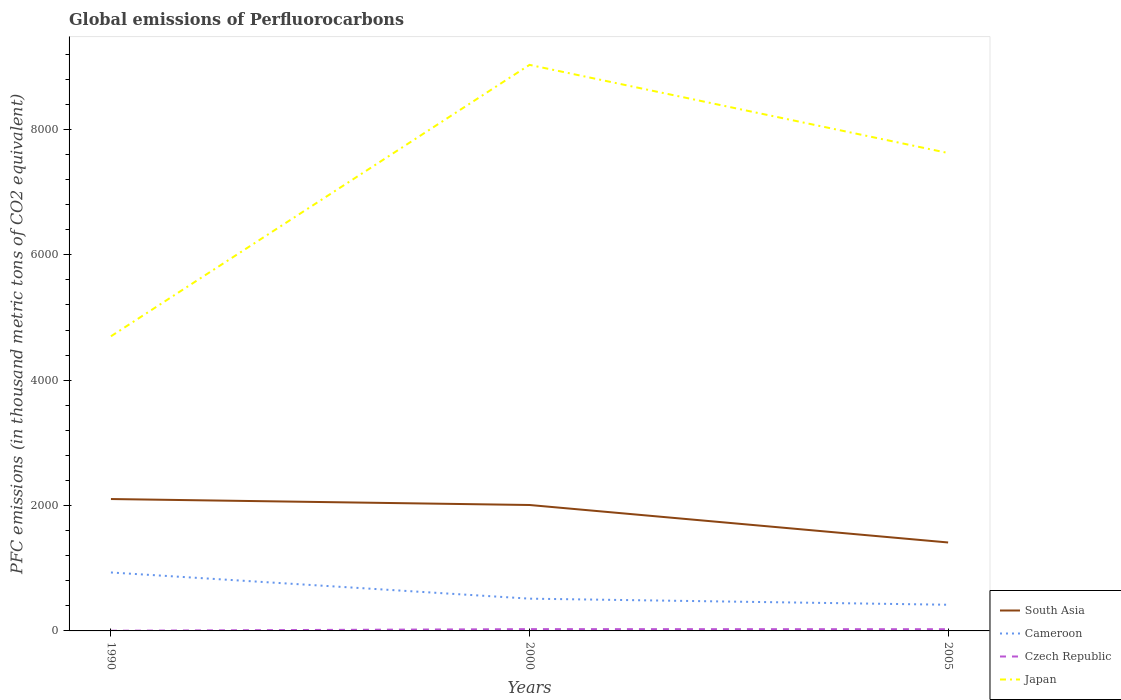How many different coloured lines are there?
Offer a very short reply. 4. Is the number of lines equal to the number of legend labels?
Keep it short and to the point. Yes. Across all years, what is the maximum global emissions of Perfluorocarbons in South Asia?
Your response must be concise. 1410.84. What is the total global emissions of Perfluorocarbons in South Asia in the graph?
Offer a terse response. 95.2. What is the difference between the highest and the second highest global emissions of Perfluorocarbons in Japan?
Provide a succinct answer. 4329.8. Is the global emissions of Perfluorocarbons in South Asia strictly greater than the global emissions of Perfluorocarbons in Czech Republic over the years?
Your response must be concise. No. Does the graph contain any zero values?
Your answer should be compact. No. Does the graph contain grids?
Keep it short and to the point. No. How are the legend labels stacked?
Provide a succinct answer. Vertical. What is the title of the graph?
Offer a terse response. Global emissions of Perfluorocarbons. What is the label or title of the Y-axis?
Your answer should be compact. PFC emissions (in thousand metric tons of CO2 equivalent). What is the PFC emissions (in thousand metric tons of CO2 equivalent) of South Asia in 1990?
Offer a very short reply. 2104. What is the PFC emissions (in thousand metric tons of CO2 equivalent) in Cameroon in 1990?
Keep it short and to the point. 932.3. What is the PFC emissions (in thousand metric tons of CO2 equivalent) of Czech Republic in 1990?
Give a very brief answer. 2.8. What is the PFC emissions (in thousand metric tons of CO2 equivalent) of Japan in 1990?
Your answer should be compact. 4700. What is the PFC emissions (in thousand metric tons of CO2 equivalent) of South Asia in 2000?
Keep it short and to the point. 2008.8. What is the PFC emissions (in thousand metric tons of CO2 equivalent) in Cameroon in 2000?
Make the answer very short. 514.7. What is the PFC emissions (in thousand metric tons of CO2 equivalent) of Czech Republic in 2000?
Offer a very short reply. 28.8. What is the PFC emissions (in thousand metric tons of CO2 equivalent) of Japan in 2000?
Offer a very short reply. 9029.8. What is the PFC emissions (in thousand metric tons of CO2 equivalent) of South Asia in 2005?
Ensure brevity in your answer.  1410.84. What is the PFC emissions (in thousand metric tons of CO2 equivalent) of Cameroon in 2005?
Ensure brevity in your answer.  417.5. What is the PFC emissions (in thousand metric tons of CO2 equivalent) of Japan in 2005?
Make the answer very short. 7623.6. Across all years, what is the maximum PFC emissions (in thousand metric tons of CO2 equivalent) in South Asia?
Your answer should be compact. 2104. Across all years, what is the maximum PFC emissions (in thousand metric tons of CO2 equivalent) of Cameroon?
Give a very brief answer. 932.3. Across all years, what is the maximum PFC emissions (in thousand metric tons of CO2 equivalent) of Czech Republic?
Provide a short and direct response. 28.8. Across all years, what is the maximum PFC emissions (in thousand metric tons of CO2 equivalent) in Japan?
Make the answer very short. 9029.8. Across all years, what is the minimum PFC emissions (in thousand metric tons of CO2 equivalent) of South Asia?
Your answer should be compact. 1410.84. Across all years, what is the minimum PFC emissions (in thousand metric tons of CO2 equivalent) of Cameroon?
Give a very brief answer. 417.5. Across all years, what is the minimum PFC emissions (in thousand metric tons of CO2 equivalent) in Czech Republic?
Your answer should be compact. 2.8. Across all years, what is the minimum PFC emissions (in thousand metric tons of CO2 equivalent) in Japan?
Give a very brief answer. 4700. What is the total PFC emissions (in thousand metric tons of CO2 equivalent) of South Asia in the graph?
Offer a very short reply. 5523.64. What is the total PFC emissions (in thousand metric tons of CO2 equivalent) in Cameroon in the graph?
Provide a short and direct response. 1864.5. What is the total PFC emissions (in thousand metric tons of CO2 equivalent) of Czech Republic in the graph?
Ensure brevity in your answer.  59.1. What is the total PFC emissions (in thousand metric tons of CO2 equivalent) in Japan in the graph?
Offer a very short reply. 2.14e+04. What is the difference between the PFC emissions (in thousand metric tons of CO2 equivalent) of South Asia in 1990 and that in 2000?
Your response must be concise. 95.2. What is the difference between the PFC emissions (in thousand metric tons of CO2 equivalent) of Cameroon in 1990 and that in 2000?
Provide a succinct answer. 417.6. What is the difference between the PFC emissions (in thousand metric tons of CO2 equivalent) in Japan in 1990 and that in 2000?
Your answer should be compact. -4329.8. What is the difference between the PFC emissions (in thousand metric tons of CO2 equivalent) of South Asia in 1990 and that in 2005?
Ensure brevity in your answer.  693.16. What is the difference between the PFC emissions (in thousand metric tons of CO2 equivalent) in Cameroon in 1990 and that in 2005?
Keep it short and to the point. 514.8. What is the difference between the PFC emissions (in thousand metric tons of CO2 equivalent) of Czech Republic in 1990 and that in 2005?
Offer a terse response. -24.7. What is the difference between the PFC emissions (in thousand metric tons of CO2 equivalent) in Japan in 1990 and that in 2005?
Provide a short and direct response. -2923.6. What is the difference between the PFC emissions (in thousand metric tons of CO2 equivalent) in South Asia in 2000 and that in 2005?
Ensure brevity in your answer.  597.96. What is the difference between the PFC emissions (in thousand metric tons of CO2 equivalent) of Cameroon in 2000 and that in 2005?
Your answer should be compact. 97.2. What is the difference between the PFC emissions (in thousand metric tons of CO2 equivalent) of Japan in 2000 and that in 2005?
Keep it short and to the point. 1406.2. What is the difference between the PFC emissions (in thousand metric tons of CO2 equivalent) in South Asia in 1990 and the PFC emissions (in thousand metric tons of CO2 equivalent) in Cameroon in 2000?
Give a very brief answer. 1589.3. What is the difference between the PFC emissions (in thousand metric tons of CO2 equivalent) in South Asia in 1990 and the PFC emissions (in thousand metric tons of CO2 equivalent) in Czech Republic in 2000?
Your answer should be very brief. 2075.2. What is the difference between the PFC emissions (in thousand metric tons of CO2 equivalent) of South Asia in 1990 and the PFC emissions (in thousand metric tons of CO2 equivalent) of Japan in 2000?
Keep it short and to the point. -6925.8. What is the difference between the PFC emissions (in thousand metric tons of CO2 equivalent) in Cameroon in 1990 and the PFC emissions (in thousand metric tons of CO2 equivalent) in Czech Republic in 2000?
Provide a succinct answer. 903.5. What is the difference between the PFC emissions (in thousand metric tons of CO2 equivalent) in Cameroon in 1990 and the PFC emissions (in thousand metric tons of CO2 equivalent) in Japan in 2000?
Your answer should be very brief. -8097.5. What is the difference between the PFC emissions (in thousand metric tons of CO2 equivalent) in Czech Republic in 1990 and the PFC emissions (in thousand metric tons of CO2 equivalent) in Japan in 2000?
Your answer should be very brief. -9027. What is the difference between the PFC emissions (in thousand metric tons of CO2 equivalent) in South Asia in 1990 and the PFC emissions (in thousand metric tons of CO2 equivalent) in Cameroon in 2005?
Keep it short and to the point. 1686.5. What is the difference between the PFC emissions (in thousand metric tons of CO2 equivalent) in South Asia in 1990 and the PFC emissions (in thousand metric tons of CO2 equivalent) in Czech Republic in 2005?
Provide a short and direct response. 2076.5. What is the difference between the PFC emissions (in thousand metric tons of CO2 equivalent) of South Asia in 1990 and the PFC emissions (in thousand metric tons of CO2 equivalent) of Japan in 2005?
Offer a terse response. -5519.6. What is the difference between the PFC emissions (in thousand metric tons of CO2 equivalent) in Cameroon in 1990 and the PFC emissions (in thousand metric tons of CO2 equivalent) in Czech Republic in 2005?
Give a very brief answer. 904.8. What is the difference between the PFC emissions (in thousand metric tons of CO2 equivalent) in Cameroon in 1990 and the PFC emissions (in thousand metric tons of CO2 equivalent) in Japan in 2005?
Your response must be concise. -6691.3. What is the difference between the PFC emissions (in thousand metric tons of CO2 equivalent) in Czech Republic in 1990 and the PFC emissions (in thousand metric tons of CO2 equivalent) in Japan in 2005?
Your answer should be very brief. -7620.8. What is the difference between the PFC emissions (in thousand metric tons of CO2 equivalent) of South Asia in 2000 and the PFC emissions (in thousand metric tons of CO2 equivalent) of Cameroon in 2005?
Provide a succinct answer. 1591.3. What is the difference between the PFC emissions (in thousand metric tons of CO2 equivalent) of South Asia in 2000 and the PFC emissions (in thousand metric tons of CO2 equivalent) of Czech Republic in 2005?
Offer a very short reply. 1981.3. What is the difference between the PFC emissions (in thousand metric tons of CO2 equivalent) in South Asia in 2000 and the PFC emissions (in thousand metric tons of CO2 equivalent) in Japan in 2005?
Give a very brief answer. -5614.8. What is the difference between the PFC emissions (in thousand metric tons of CO2 equivalent) of Cameroon in 2000 and the PFC emissions (in thousand metric tons of CO2 equivalent) of Czech Republic in 2005?
Provide a succinct answer. 487.2. What is the difference between the PFC emissions (in thousand metric tons of CO2 equivalent) in Cameroon in 2000 and the PFC emissions (in thousand metric tons of CO2 equivalent) in Japan in 2005?
Keep it short and to the point. -7108.9. What is the difference between the PFC emissions (in thousand metric tons of CO2 equivalent) in Czech Republic in 2000 and the PFC emissions (in thousand metric tons of CO2 equivalent) in Japan in 2005?
Offer a very short reply. -7594.8. What is the average PFC emissions (in thousand metric tons of CO2 equivalent) of South Asia per year?
Make the answer very short. 1841.21. What is the average PFC emissions (in thousand metric tons of CO2 equivalent) of Cameroon per year?
Make the answer very short. 621.5. What is the average PFC emissions (in thousand metric tons of CO2 equivalent) of Japan per year?
Give a very brief answer. 7117.8. In the year 1990, what is the difference between the PFC emissions (in thousand metric tons of CO2 equivalent) in South Asia and PFC emissions (in thousand metric tons of CO2 equivalent) in Cameroon?
Keep it short and to the point. 1171.7. In the year 1990, what is the difference between the PFC emissions (in thousand metric tons of CO2 equivalent) in South Asia and PFC emissions (in thousand metric tons of CO2 equivalent) in Czech Republic?
Your answer should be compact. 2101.2. In the year 1990, what is the difference between the PFC emissions (in thousand metric tons of CO2 equivalent) of South Asia and PFC emissions (in thousand metric tons of CO2 equivalent) of Japan?
Give a very brief answer. -2596. In the year 1990, what is the difference between the PFC emissions (in thousand metric tons of CO2 equivalent) in Cameroon and PFC emissions (in thousand metric tons of CO2 equivalent) in Czech Republic?
Ensure brevity in your answer.  929.5. In the year 1990, what is the difference between the PFC emissions (in thousand metric tons of CO2 equivalent) of Cameroon and PFC emissions (in thousand metric tons of CO2 equivalent) of Japan?
Your response must be concise. -3767.7. In the year 1990, what is the difference between the PFC emissions (in thousand metric tons of CO2 equivalent) of Czech Republic and PFC emissions (in thousand metric tons of CO2 equivalent) of Japan?
Your answer should be compact. -4697.2. In the year 2000, what is the difference between the PFC emissions (in thousand metric tons of CO2 equivalent) of South Asia and PFC emissions (in thousand metric tons of CO2 equivalent) of Cameroon?
Provide a short and direct response. 1494.1. In the year 2000, what is the difference between the PFC emissions (in thousand metric tons of CO2 equivalent) of South Asia and PFC emissions (in thousand metric tons of CO2 equivalent) of Czech Republic?
Your response must be concise. 1980. In the year 2000, what is the difference between the PFC emissions (in thousand metric tons of CO2 equivalent) in South Asia and PFC emissions (in thousand metric tons of CO2 equivalent) in Japan?
Your answer should be very brief. -7021. In the year 2000, what is the difference between the PFC emissions (in thousand metric tons of CO2 equivalent) of Cameroon and PFC emissions (in thousand metric tons of CO2 equivalent) of Czech Republic?
Offer a very short reply. 485.9. In the year 2000, what is the difference between the PFC emissions (in thousand metric tons of CO2 equivalent) in Cameroon and PFC emissions (in thousand metric tons of CO2 equivalent) in Japan?
Make the answer very short. -8515.1. In the year 2000, what is the difference between the PFC emissions (in thousand metric tons of CO2 equivalent) in Czech Republic and PFC emissions (in thousand metric tons of CO2 equivalent) in Japan?
Provide a short and direct response. -9001. In the year 2005, what is the difference between the PFC emissions (in thousand metric tons of CO2 equivalent) in South Asia and PFC emissions (in thousand metric tons of CO2 equivalent) in Cameroon?
Offer a terse response. 993.34. In the year 2005, what is the difference between the PFC emissions (in thousand metric tons of CO2 equivalent) in South Asia and PFC emissions (in thousand metric tons of CO2 equivalent) in Czech Republic?
Make the answer very short. 1383.34. In the year 2005, what is the difference between the PFC emissions (in thousand metric tons of CO2 equivalent) of South Asia and PFC emissions (in thousand metric tons of CO2 equivalent) of Japan?
Offer a very short reply. -6212.76. In the year 2005, what is the difference between the PFC emissions (in thousand metric tons of CO2 equivalent) of Cameroon and PFC emissions (in thousand metric tons of CO2 equivalent) of Czech Republic?
Offer a terse response. 390. In the year 2005, what is the difference between the PFC emissions (in thousand metric tons of CO2 equivalent) in Cameroon and PFC emissions (in thousand metric tons of CO2 equivalent) in Japan?
Offer a very short reply. -7206.1. In the year 2005, what is the difference between the PFC emissions (in thousand metric tons of CO2 equivalent) in Czech Republic and PFC emissions (in thousand metric tons of CO2 equivalent) in Japan?
Your answer should be very brief. -7596.1. What is the ratio of the PFC emissions (in thousand metric tons of CO2 equivalent) of South Asia in 1990 to that in 2000?
Offer a terse response. 1.05. What is the ratio of the PFC emissions (in thousand metric tons of CO2 equivalent) of Cameroon in 1990 to that in 2000?
Your answer should be compact. 1.81. What is the ratio of the PFC emissions (in thousand metric tons of CO2 equivalent) of Czech Republic in 1990 to that in 2000?
Provide a succinct answer. 0.1. What is the ratio of the PFC emissions (in thousand metric tons of CO2 equivalent) in Japan in 1990 to that in 2000?
Your answer should be very brief. 0.52. What is the ratio of the PFC emissions (in thousand metric tons of CO2 equivalent) of South Asia in 1990 to that in 2005?
Offer a very short reply. 1.49. What is the ratio of the PFC emissions (in thousand metric tons of CO2 equivalent) in Cameroon in 1990 to that in 2005?
Ensure brevity in your answer.  2.23. What is the ratio of the PFC emissions (in thousand metric tons of CO2 equivalent) in Czech Republic in 1990 to that in 2005?
Your answer should be compact. 0.1. What is the ratio of the PFC emissions (in thousand metric tons of CO2 equivalent) in Japan in 1990 to that in 2005?
Provide a succinct answer. 0.62. What is the ratio of the PFC emissions (in thousand metric tons of CO2 equivalent) of South Asia in 2000 to that in 2005?
Make the answer very short. 1.42. What is the ratio of the PFC emissions (in thousand metric tons of CO2 equivalent) of Cameroon in 2000 to that in 2005?
Offer a terse response. 1.23. What is the ratio of the PFC emissions (in thousand metric tons of CO2 equivalent) of Czech Republic in 2000 to that in 2005?
Your answer should be very brief. 1.05. What is the ratio of the PFC emissions (in thousand metric tons of CO2 equivalent) of Japan in 2000 to that in 2005?
Your answer should be very brief. 1.18. What is the difference between the highest and the second highest PFC emissions (in thousand metric tons of CO2 equivalent) in South Asia?
Give a very brief answer. 95.2. What is the difference between the highest and the second highest PFC emissions (in thousand metric tons of CO2 equivalent) of Cameroon?
Your response must be concise. 417.6. What is the difference between the highest and the second highest PFC emissions (in thousand metric tons of CO2 equivalent) of Japan?
Make the answer very short. 1406.2. What is the difference between the highest and the lowest PFC emissions (in thousand metric tons of CO2 equivalent) of South Asia?
Give a very brief answer. 693.16. What is the difference between the highest and the lowest PFC emissions (in thousand metric tons of CO2 equivalent) of Cameroon?
Keep it short and to the point. 514.8. What is the difference between the highest and the lowest PFC emissions (in thousand metric tons of CO2 equivalent) of Japan?
Your response must be concise. 4329.8. 